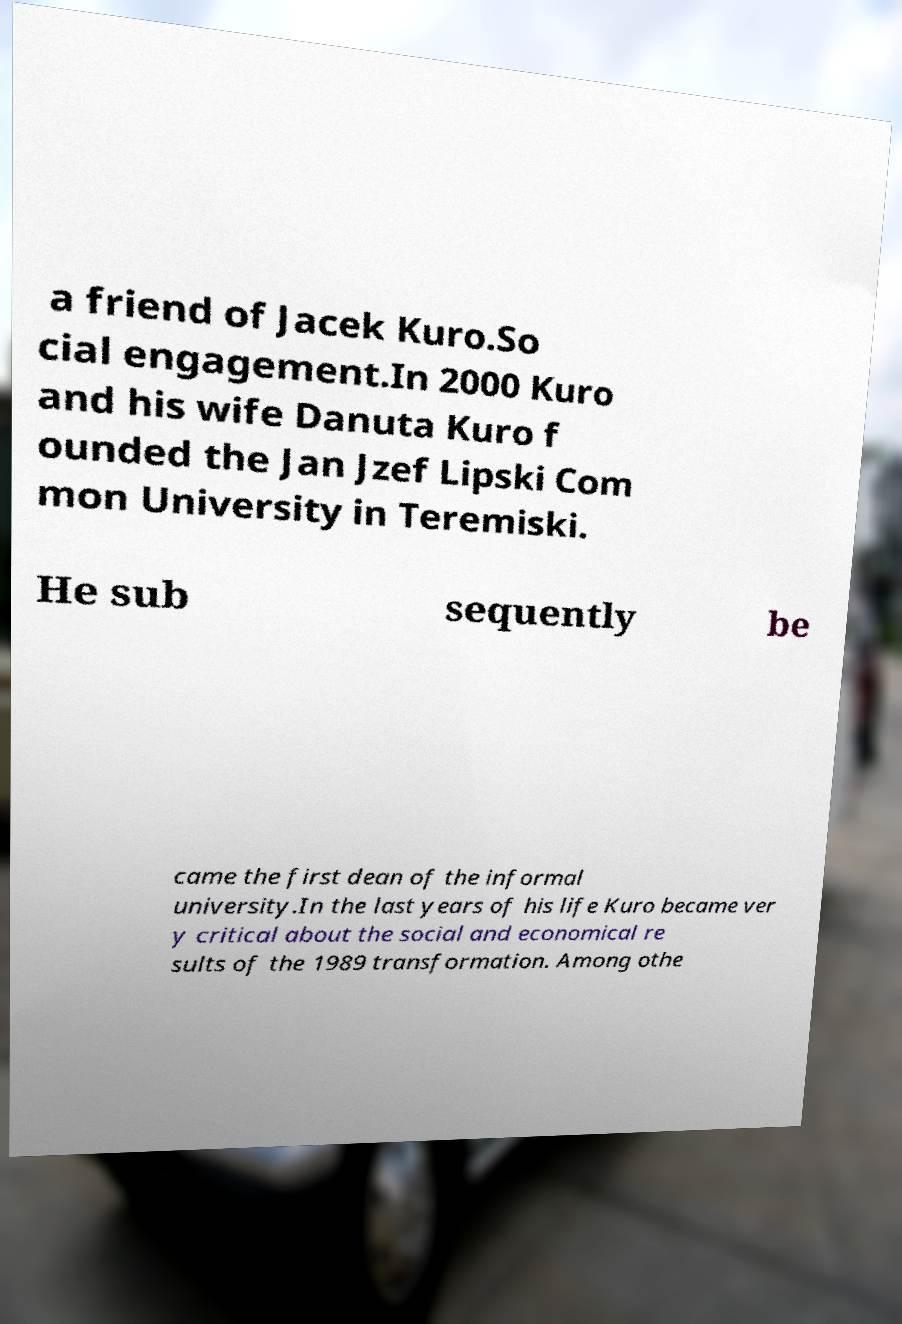For documentation purposes, I need the text within this image transcribed. Could you provide that? a friend of Jacek Kuro.So cial engagement.In 2000 Kuro and his wife Danuta Kuro f ounded the Jan Jzef Lipski Com mon University in Teremiski. He sub sequently be came the first dean of the informal university.In the last years of his life Kuro became ver y critical about the social and economical re sults of the 1989 transformation. Among othe 